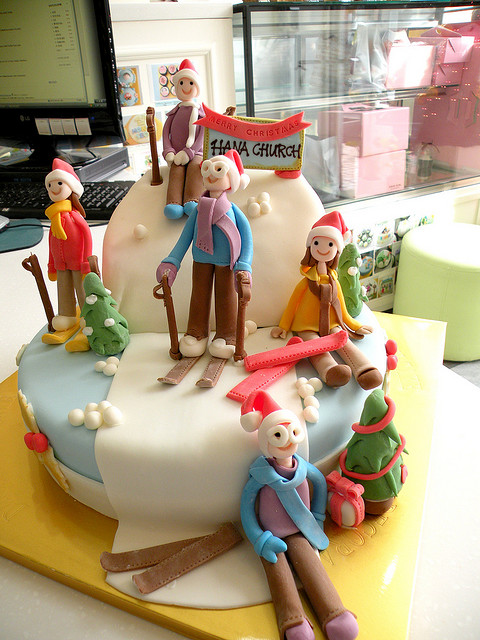Please transcribe the text in this image. CHURCH hana MERRY CHRISTMAS 